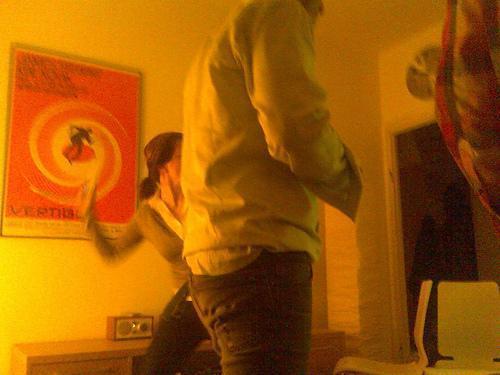How many chairs are visible?
Give a very brief answer. 2. How many people can be seen?
Give a very brief answer. 2. 